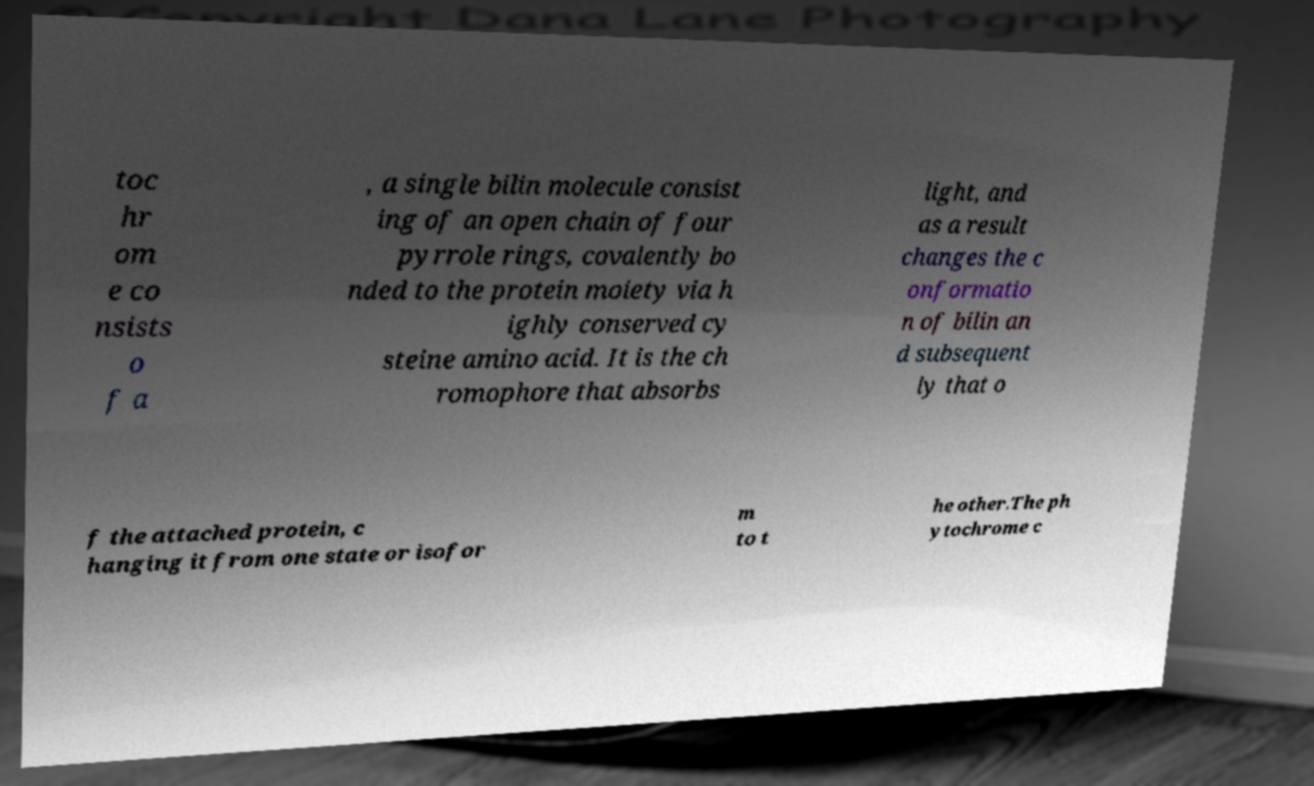Please read and relay the text visible in this image. What does it say? toc hr om e co nsists o f a , a single bilin molecule consist ing of an open chain of four pyrrole rings, covalently bo nded to the protein moiety via h ighly conserved cy steine amino acid. It is the ch romophore that absorbs light, and as a result changes the c onformatio n of bilin an d subsequent ly that o f the attached protein, c hanging it from one state or isofor m to t he other.The ph ytochrome c 